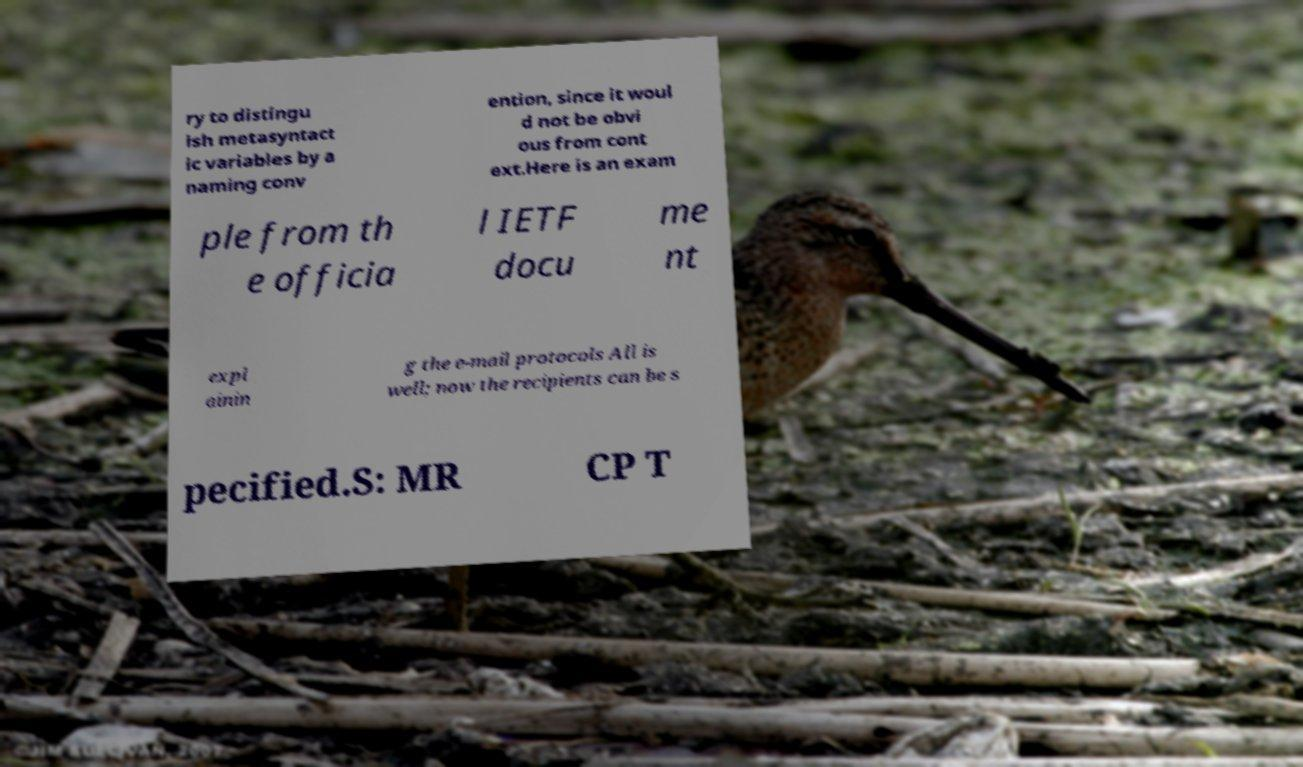I need the written content from this picture converted into text. Can you do that? ry to distingu ish metasyntact ic variables by a naming conv ention, since it woul d not be obvi ous from cont ext.Here is an exam ple from th e officia l IETF docu me nt expl ainin g the e-mail protocols All is well; now the recipients can be s pecified.S: MR CP T 